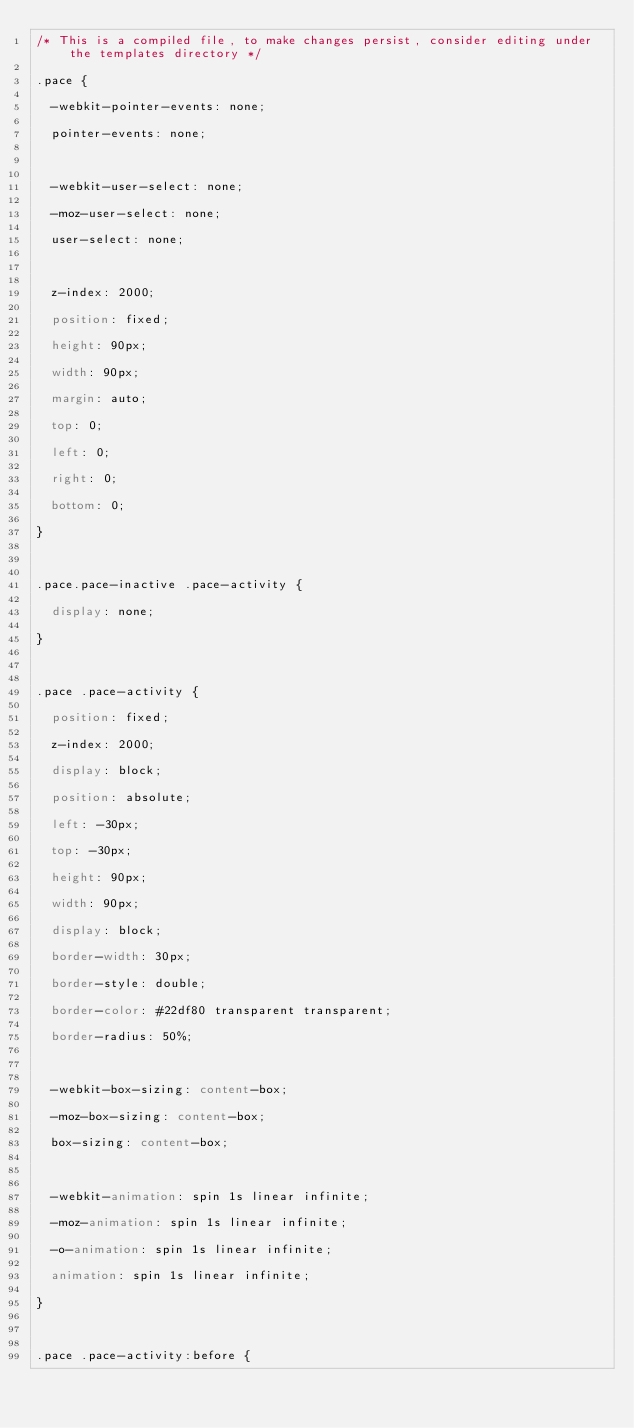Convert code to text. <code><loc_0><loc_0><loc_500><loc_500><_CSS_>/* This is a compiled file, to make changes persist, consider editing under the templates directory */
.pace {
  -webkit-pointer-events: none;
  pointer-events: none;

  -webkit-user-select: none;
  -moz-user-select: none;
  user-select: none;

  z-index: 2000;
  position: fixed;
  height: 90px;
  width: 90px;
  margin: auto;
  top: 0;
  left: 0;
  right: 0;
  bottom: 0;
}

.pace.pace-inactive .pace-activity {
  display: none;
}

.pace .pace-activity {
  position: fixed;
  z-index: 2000;
  display: block;
  position: absolute;
  left: -30px;
  top: -30px;
  height: 90px;
  width: 90px;
  display: block;
  border-width: 30px;
  border-style: double;
  border-color: #22df80 transparent transparent;
  border-radius: 50%;

  -webkit-box-sizing: content-box;
  -moz-box-sizing: content-box;
  box-sizing: content-box;

  -webkit-animation: spin 1s linear infinite;
  -moz-animation: spin 1s linear infinite;
  -o-animation: spin 1s linear infinite;
  animation: spin 1s linear infinite;
}

.pace .pace-activity:before {</code> 